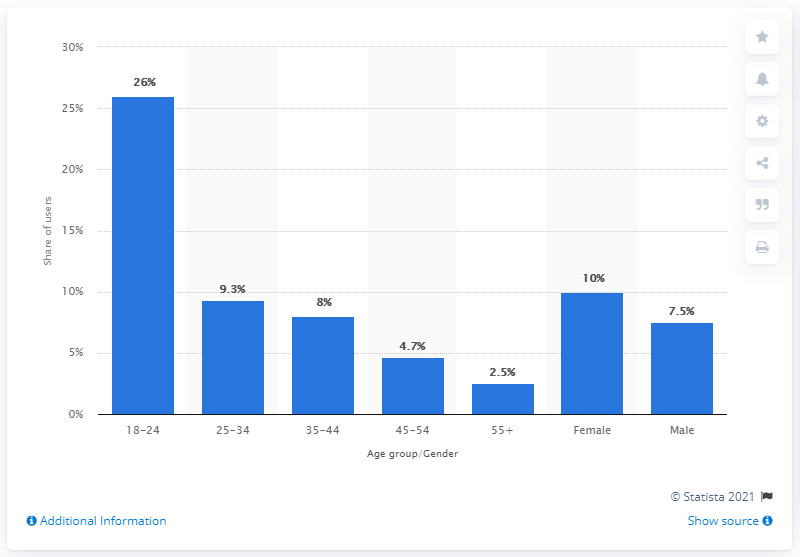List a handful of essential elements in this visual. According to the data, 9.3% of 25 to 34 year olds used the TikTok app in a certain time period. 